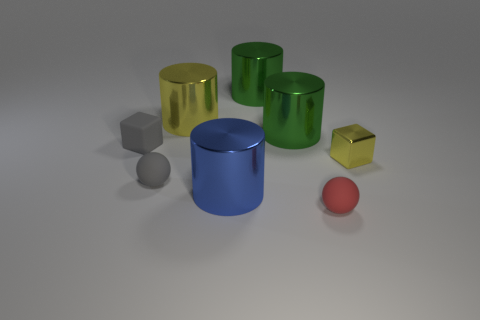Add 1 gray rubber balls. How many objects exist? 9 Subtract all spheres. How many objects are left? 6 Subtract all cylinders. Subtract all big brown cubes. How many objects are left? 4 Add 4 gray objects. How many gray objects are left? 6 Add 2 purple balls. How many purple balls exist? 2 Subtract 1 blue cylinders. How many objects are left? 7 